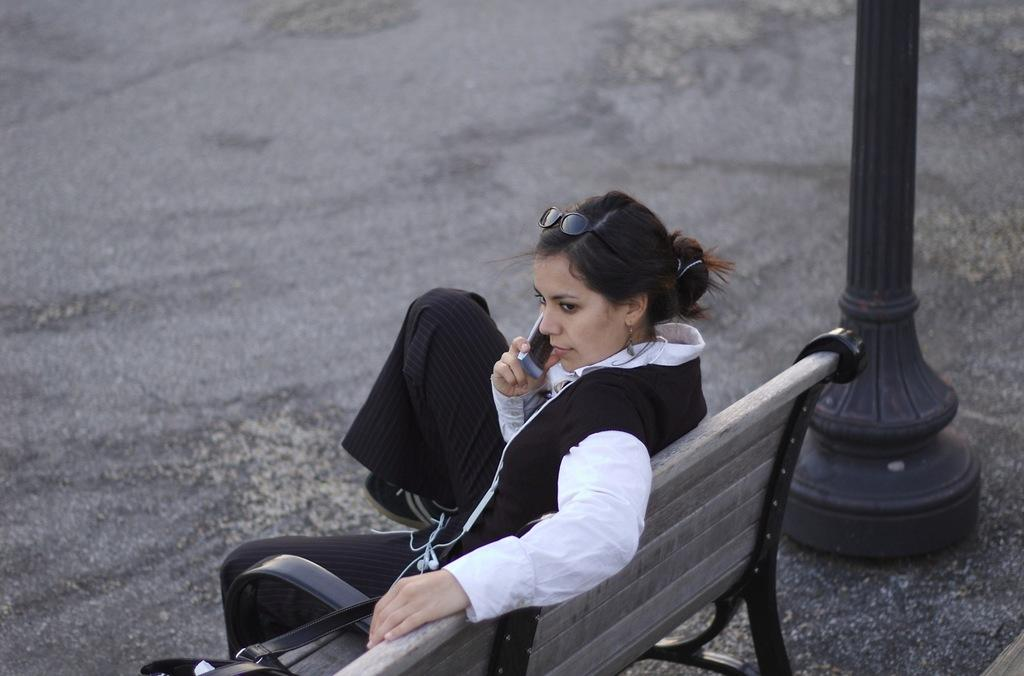What is the woman in the image doing? The woman is sitting on a bench in the image. What is the woman holding in the image? The woman is holding a mobile in the image. Can you describe any other objects or structures in the image? There is a pole in the image. What type of poison can be seen on the wall in the image? There is no wall or poison present in the image. How does the zephyr affect the woman sitting on the bench in the image? There is no zephyr present in the image, so it cannot affect the woman. 